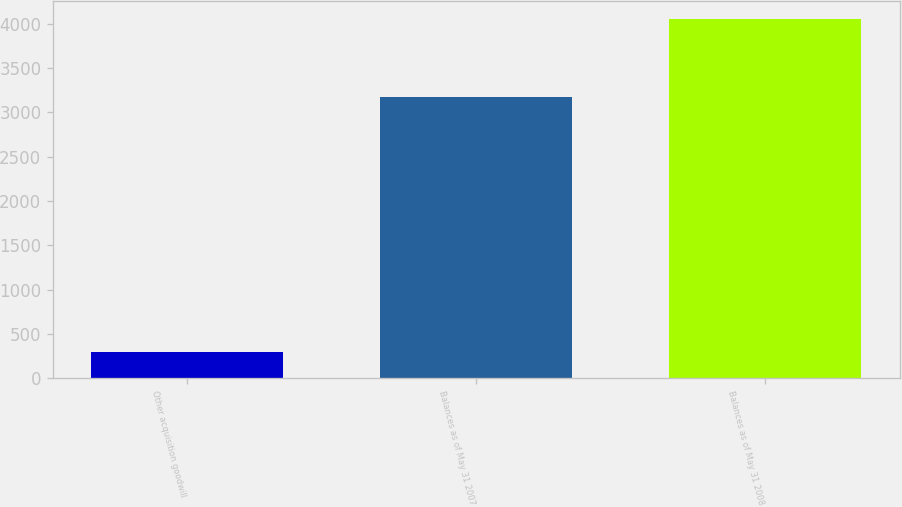Convert chart to OTSL. <chart><loc_0><loc_0><loc_500><loc_500><bar_chart><fcel>Other acquisition goodwill<fcel>Balances as of May 31 2007<fcel>Balances as of May 31 2008<nl><fcel>295<fcel>3169<fcel>4058<nl></chart> 